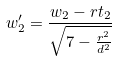Convert formula to latex. <formula><loc_0><loc_0><loc_500><loc_500>w _ { 2 } ^ { \prime } = \frac { w _ { 2 } - r t _ { 2 } } { \sqrt { 7 - \frac { r ^ { 2 } } { d ^ { 2 } } } }</formula> 